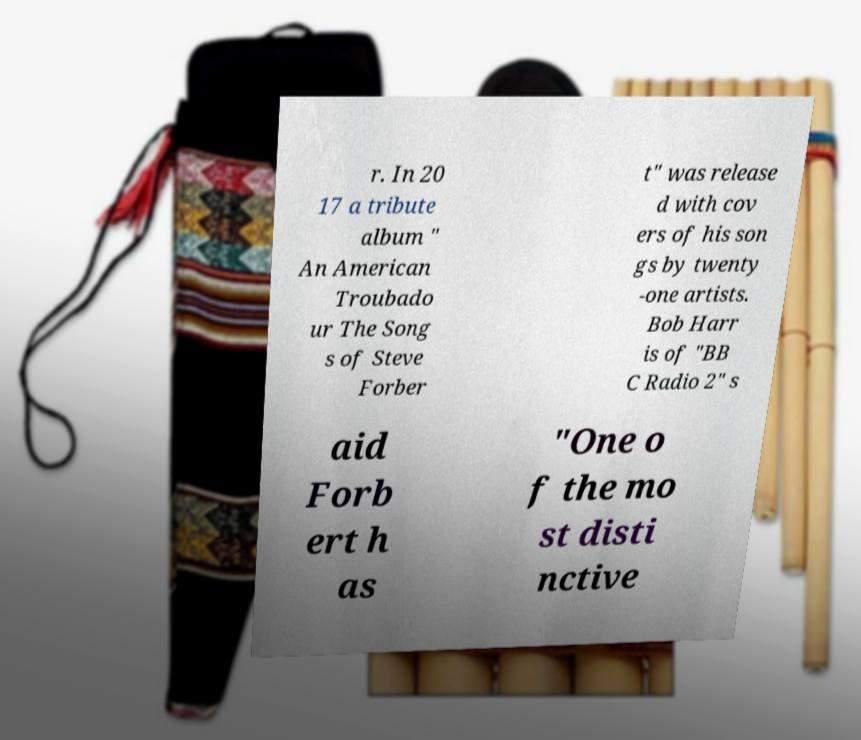Please identify and transcribe the text found in this image. r. In 20 17 a tribute album " An American Troubado ur The Song s of Steve Forber t" was release d with cov ers of his son gs by twenty -one artists. Bob Harr is of "BB C Radio 2" s aid Forb ert h as "One o f the mo st disti nctive 